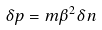<formula> <loc_0><loc_0><loc_500><loc_500>\delta p = m \beta ^ { 2 } \delta n</formula> 